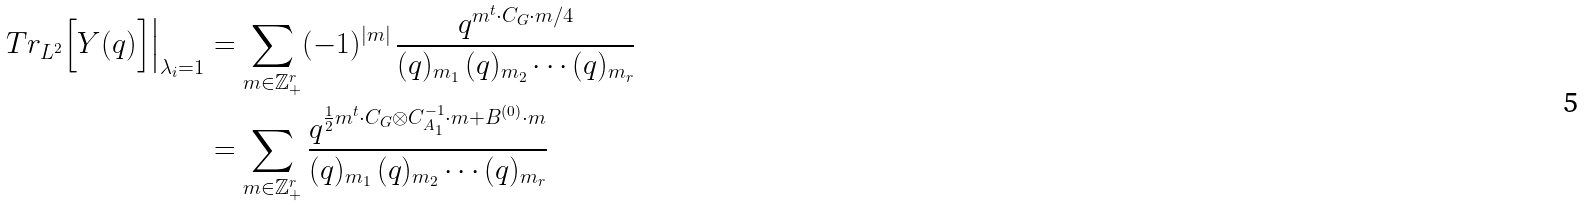Convert formula to latex. <formula><loc_0><loc_0><loc_500><loc_500>T r _ { L ^ { 2 } } \Big [ Y ( q ) \Big ] \Big | _ { \lambda _ { i } = 1 } & = \sum _ { m \in \mathbb { Z } ^ { r } _ { + } } ( - 1 ) ^ { | m | } \, \frac { q ^ { m ^ { t } \cdot C _ { G } \cdot m / 4 } } { ( q ) _ { m _ { 1 } } \, ( q ) _ { m _ { 2 } } \cdots ( q ) _ { m _ { r } } } \\ & = \sum _ { m \in \mathbb { Z } ^ { r } _ { + } } \frac { q ^ { \frac { 1 } { 2 } m ^ { t } \cdot C _ { G } \otimes C _ { A _ { 1 } } ^ { - 1 } \cdot m + B ^ { ( 0 ) } \cdot m } } { ( q ) _ { m _ { 1 } } \, ( q ) _ { m _ { 2 } } \cdots ( q ) _ { m _ { r } } }</formula> 